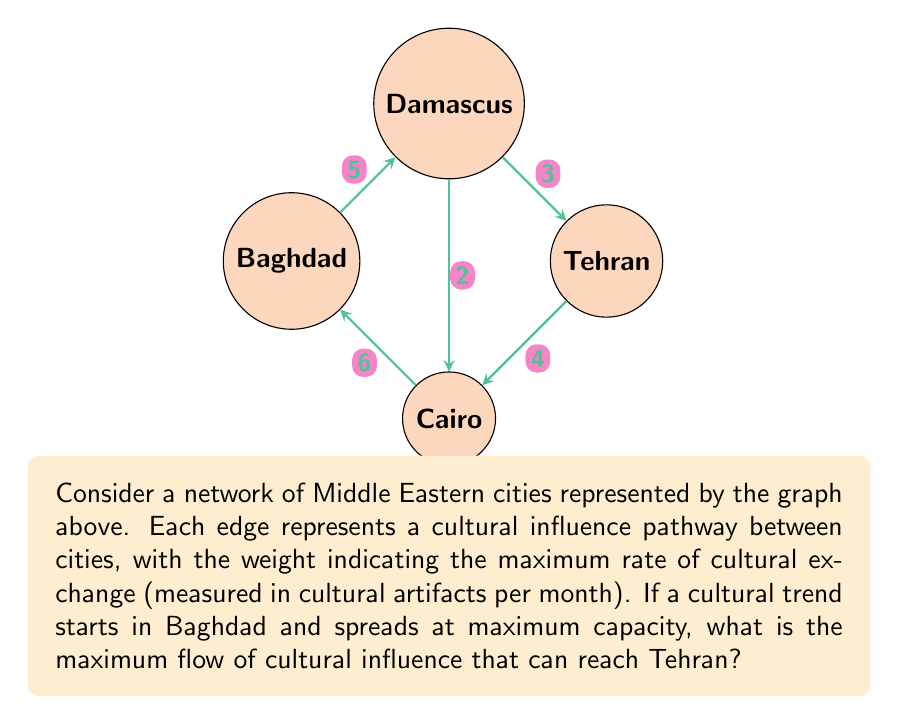Show me your answer to this math problem. To solve this problem, we'll use the Max-Flow Min-Cut theorem and apply the Ford-Fulkerson algorithm:

1) First, identify all possible paths from Baghdad to Tehran:
   Path 1: Baghdad → Damascus → Tehran
   Path 2: Baghdad → Damascus → Cairo → Tehran
   Path 3: Baghdad → Cairo → Tehran
   Path 4: Baghdad → Cairo → Damascus → Tehran

2) Start with zero flow and iteratively increase flow along augmenting paths:

   Iteration 1: Use path 1
   Baghdad → Damascus (5/5)
   Damascus → Tehran (3/3)
   Flow = 3

   Iteration 2: Use path 3
   Baghdad → Cairo (5/6)
   Cairo → Tehran (4/4)
   Flow = 3 + 4 = 7

   Iteration 3: Use path 2
   Baghdad → Damascus (1/5)
   Damascus → Cairo (1/2)
   Cairo → Tehran (1/4)
   Flow = 7 + 1 = 8

3) No more augmenting paths exist, so the maximum flow is 8.

4) Verify using the Min-Cut:
   The minimum cut is {Baghdad, Damascus, Cairo} | {Tehran}
   Capacity of this cut: 3 + 4 + 1 = 8, which matches our max flow.

Therefore, the maximum flow of cultural influence from Baghdad to Tehran is 8 cultural artifacts per month.
Answer: 8 cultural artifacts per month 